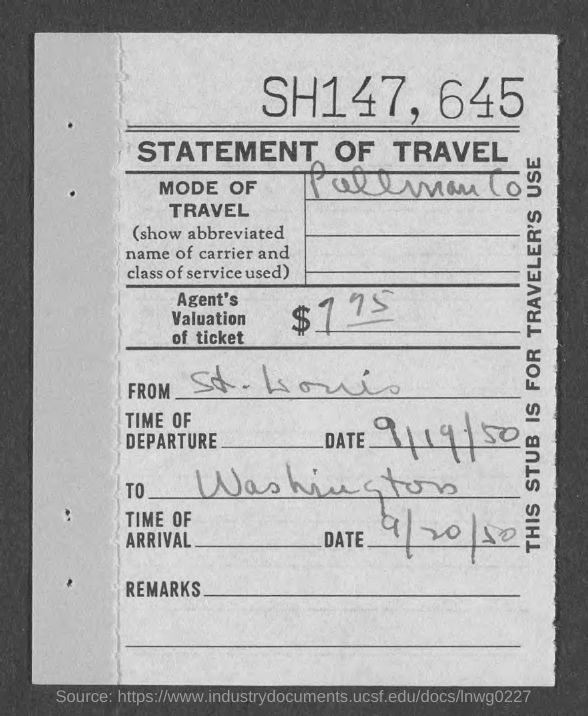What kind of statement is given here?
Offer a terse response. STATEMENT OF TRAVEL. What is the date of departure given in the statement?
Provide a succinct answer. 9/19/50. What is the date of arrival given in the statement?
Keep it short and to the point. 9/20/50. 